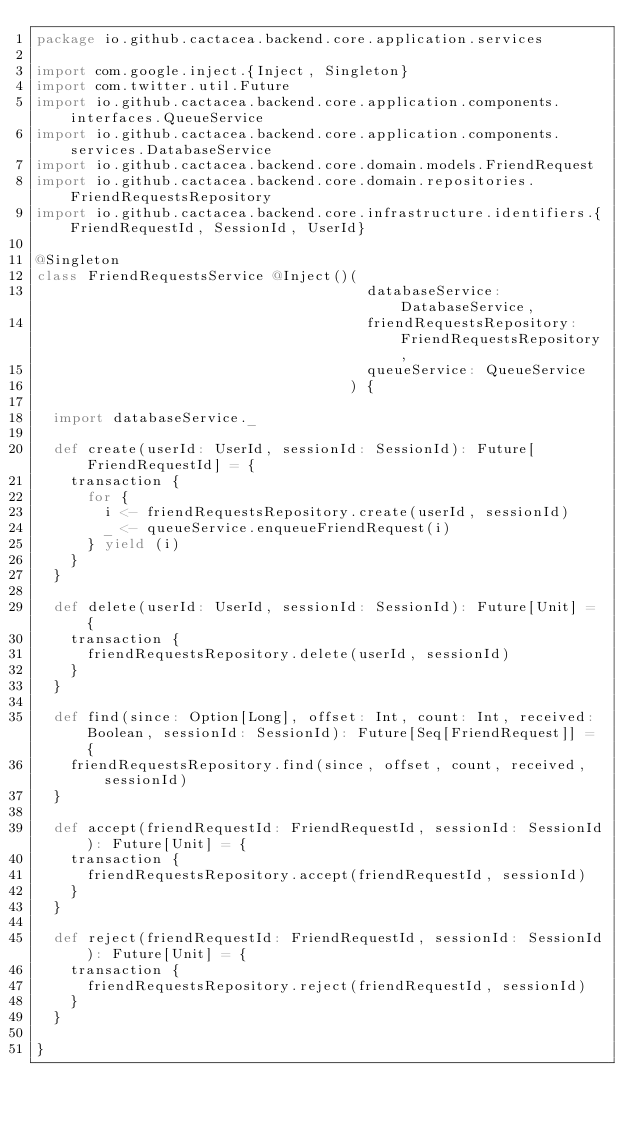<code> <loc_0><loc_0><loc_500><loc_500><_Scala_>package io.github.cactacea.backend.core.application.services

import com.google.inject.{Inject, Singleton}
import com.twitter.util.Future
import io.github.cactacea.backend.core.application.components.interfaces.QueueService
import io.github.cactacea.backend.core.application.components.services.DatabaseService
import io.github.cactacea.backend.core.domain.models.FriendRequest
import io.github.cactacea.backend.core.domain.repositories.FriendRequestsRepository
import io.github.cactacea.backend.core.infrastructure.identifiers.{FriendRequestId, SessionId, UserId}

@Singleton
class FriendRequestsService @Inject()(
                                       databaseService: DatabaseService,
                                       friendRequestsRepository: FriendRequestsRepository,
                                       queueService: QueueService
                                     ) {

  import databaseService._

  def create(userId: UserId, sessionId: SessionId): Future[FriendRequestId] = {
    transaction {
      for {
        i <- friendRequestsRepository.create(userId, sessionId)
        _ <- queueService.enqueueFriendRequest(i)
      } yield (i)
    }
  }

  def delete(userId: UserId, sessionId: SessionId): Future[Unit] = {
    transaction {
      friendRequestsRepository.delete(userId, sessionId)
    }
  }

  def find(since: Option[Long], offset: Int, count: Int, received: Boolean, sessionId: SessionId): Future[Seq[FriendRequest]] = {
    friendRequestsRepository.find(since, offset, count, received, sessionId)
  }

  def accept(friendRequestId: FriendRequestId, sessionId: SessionId): Future[Unit] = {
    transaction {
      friendRequestsRepository.accept(friendRequestId, sessionId)
    }
  }

  def reject(friendRequestId: FriendRequestId, sessionId: SessionId): Future[Unit] = {
    transaction {
      friendRequestsRepository.reject(friendRequestId, sessionId)
    }
  }

}
</code> 